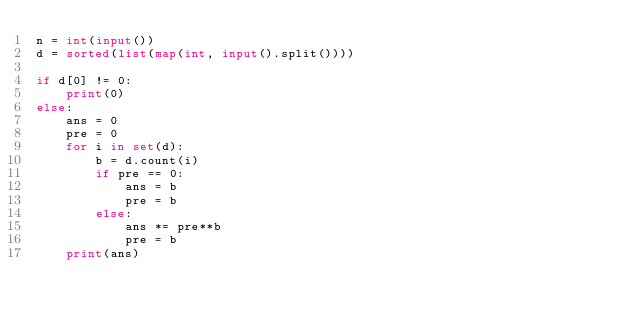Convert code to text. <code><loc_0><loc_0><loc_500><loc_500><_Python_>n = int(input())
d = sorted(list(map(int, input().split())))

if d[0] != 0:
    print(0)
else:
    ans = 0
    pre = 0
    for i in set(d):
        b = d.count(i)
        if pre == 0:
            ans = b
            pre = b
        else:
            ans *= pre**b
            pre = b
    print(ans)
</code> 